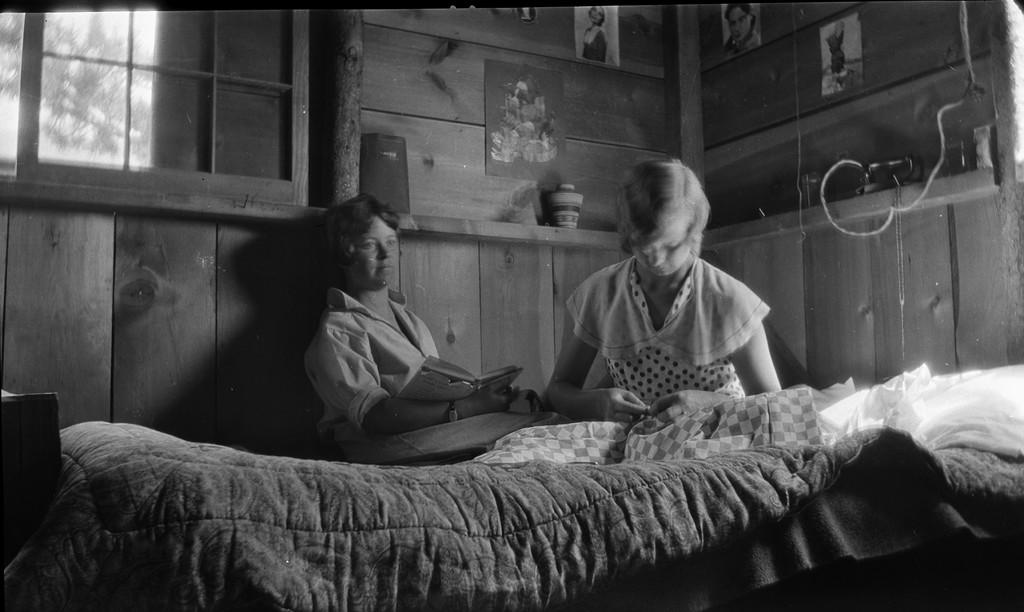How many people are in the image? There are two girls in the image. Where are the girls located in the image? The girls are on a bed. What is one of the girls holding in the image? One of the girls is holding a book. What can be seen in the background of the image? There is a wall with photos and a window in the background of the image. What type of laborer is working in the background of the image? There is no laborer present in the image; it features two girls on a bed with a book and a background that includes a wall with photos and a window. 